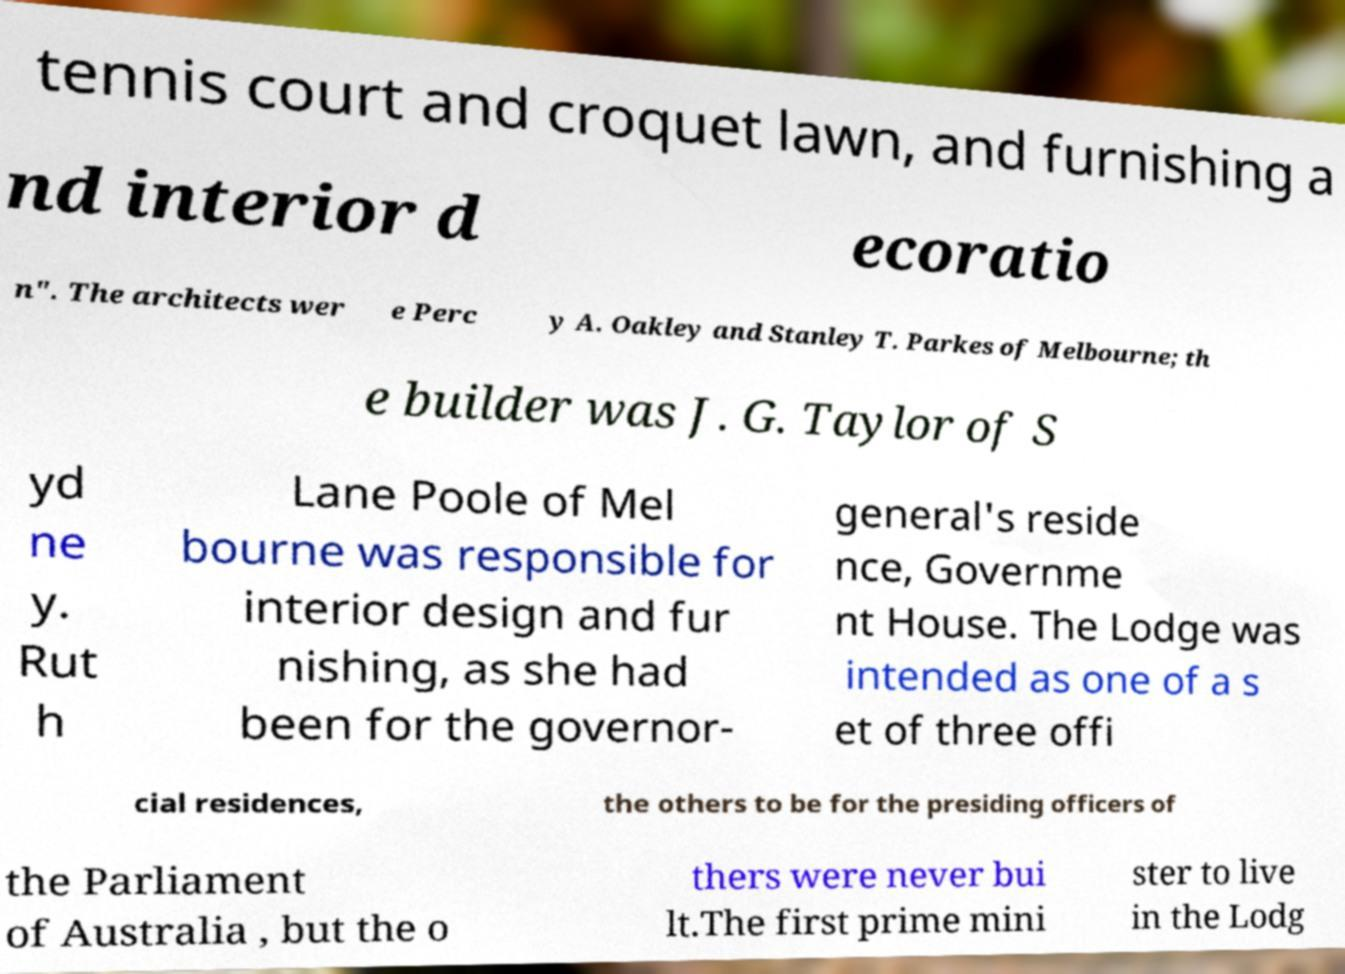For documentation purposes, I need the text within this image transcribed. Could you provide that? tennis court and croquet lawn, and furnishing a nd interior d ecoratio n". The architects wer e Perc y A. Oakley and Stanley T. Parkes of Melbourne; th e builder was J. G. Taylor of S yd ne y. Rut h Lane Poole of Mel bourne was responsible for interior design and fur nishing, as she had been for the governor- general's reside nce, Governme nt House. The Lodge was intended as one of a s et of three offi cial residences, the others to be for the presiding officers of the Parliament of Australia , but the o thers were never bui lt.The first prime mini ster to live in the Lodg 